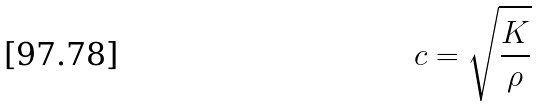<formula> <loc_0><loc_0><loc_500><loc_500>c = \sqrt { \frac { K } { \rho } }</formula> 